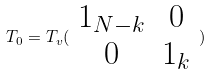<formula> <loc_0><loc_0><loc_500><loc_500>T _ { 0 } = T _ { v } ( \begin{array} { c c } 1 _ { N - k } & 0 \\ 0 & 1 _ { k } \end{array} )</formula> 